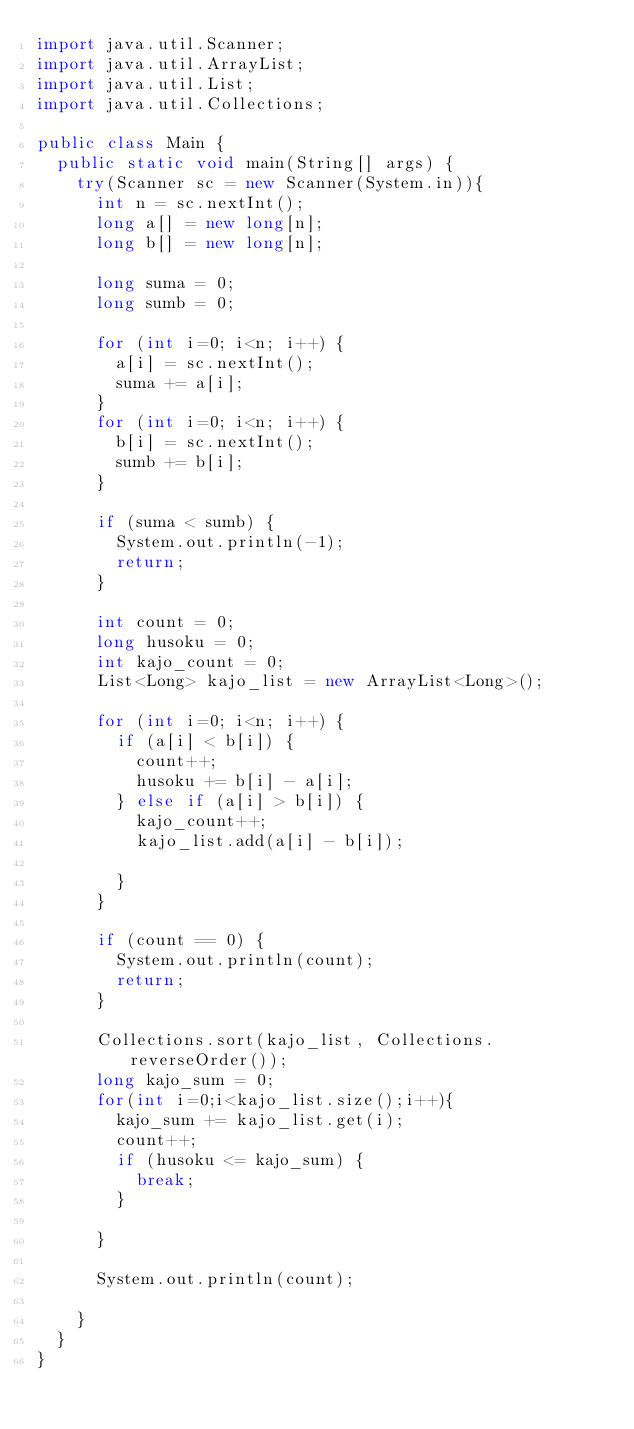<code> <loc_0><loc_0><loc_500><loc_500><_Java_>import java.util.Scanner;
import java.util.ArrayList;
import java.util.List;
import java.util.Collections;
 
public class Main {
	public static void main(String[] args) {
		try(Scanner sc = new Scanner(System.in)){
			int n = sc.nextInt();
			long a[] = new long[n];
			long b[] = new long[n];
			
			long suma = 0;
			long sumb = 0;
			
			for (int i=0; i<n; i++) {
				a[i] = sc.nextInt();
				suma += a[i];
			}
			for (int i=0; i<n; i++) {
				b[i] = sc.nextInt();
				sumb += b[i];
			}
			
			if (suma < sumb) {
				System.out.println(-1);
				return;
			}
			
			int count = 0;
			long husoku = 0;
			int kajo_count = 0;
			List<Long> kajo_list = new ArrayList<Long>();

			for (int i=0; i<n; i++) {
				if (a[i] < b[i]) {
					count++;
					husoku += b[i] - a[i];
				} else if (a[i] > b[i]) {
					kajo_count++;
					kajo_list.add(a[i] - b[i]);
					
				}
			}
			
			if (count == 0) {
				System.out.println(count);
				return;
			}
			
			Collections.sort(kajo_list, Collections.reverseOrder());
			long kajo_sum = 0;
			for(int i=0;i<kajo_list.size();i++){
				kajo_sum += kajo_list.get(i);
				count++;
				if (husoku <= kajo_sum) {
					break;
				}
				
			}
			
			System.out.println(count);

		}
	}
}</code> 